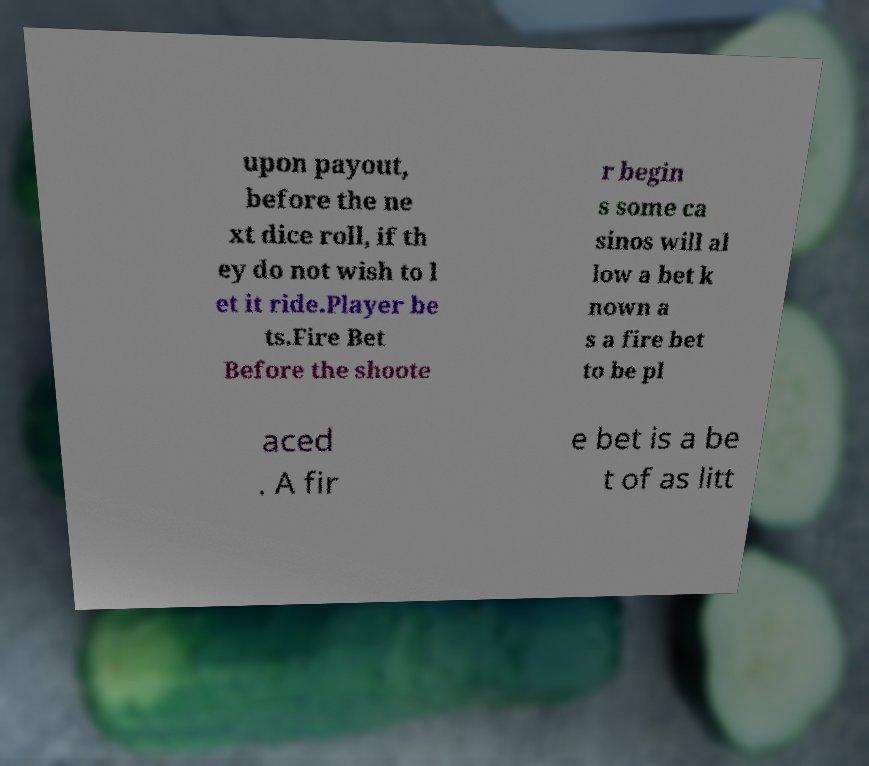I need the written content from this picture converted into text. Can you do that? upon payout, before the ne xt dice roll, if th ey do not wish to l et it ride.Player be ts.Fire Bet Before the shoote r begin s some ca sinos will al low a bet k nown a s a fire bet to be pl aced . A fir e bet is a be t of as litt 